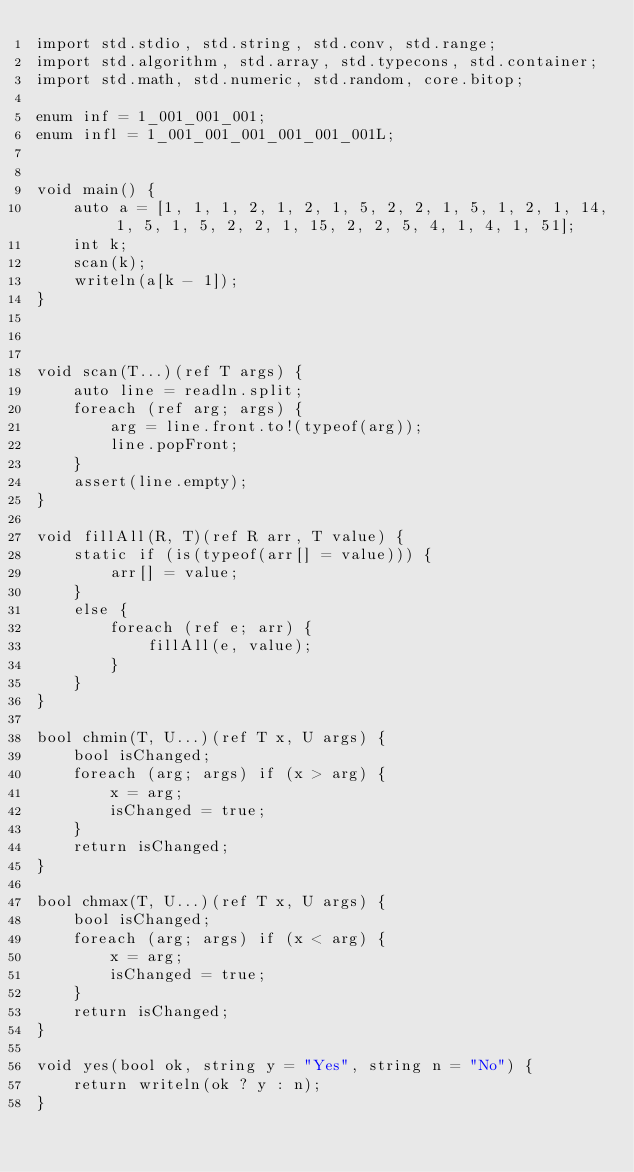<code> <loc_0><loc_0><loc_500><loc_500><_D_>import std.stdio, std.string, std.conv, std.range;
import std.algorithm, std.array, std.typecons, std.container;
import std.math, std.numeric, std.random, core.bitop;

enum inf = 1_001_001_001;
enum infl = 1_001_001_001_001_001_001L;


void main() {
    auto a = [1, 1, 1, 2, 1, 2, 1, 5, 2, 2, 1, 5, 1, 2, 1, 14, 1, 5, 1, 5, 2, 2, 1, 15, 2, 2, 5, 4, 1, 4, 1, 51];
    int k;
    scan(k);
    writeln(a[k - 1]);
}



void scan(T...)(ref T args) {
    auto line = readln.split;
    foreach (ref arg; args) {
        arg = line.front.to!(typeof(arg));
        line.popFront;
    }
    assert(line.empty);
}

void fillAll(R, T)(ref R arr, T value) {
    static if (is(typeof(arr[] = value))) {
        arr[] = value;
    }
    else {
        foreach (ref e; arr) {
            fillAll(e, value);
        }
    }
}

bool chmin(T, U...)(ref T x, U args) {
    bool isChanged;
    foreach (arg; args) if (x > arg) {
        x = arg;
        isChanged = true;
    }
    return isChanged;
}

bool chmax(T, U...)(ref T x, U args) {
    bool isChanged;
    foreach (arg; args) if (x < arg) {
        x = arg;
        isChanged = true;
    }
    return isChanged;
}

void yes(bool ok, string y = "Yes", string n = "No") {
    return writeln(ok ? y : n);
}
</code> 